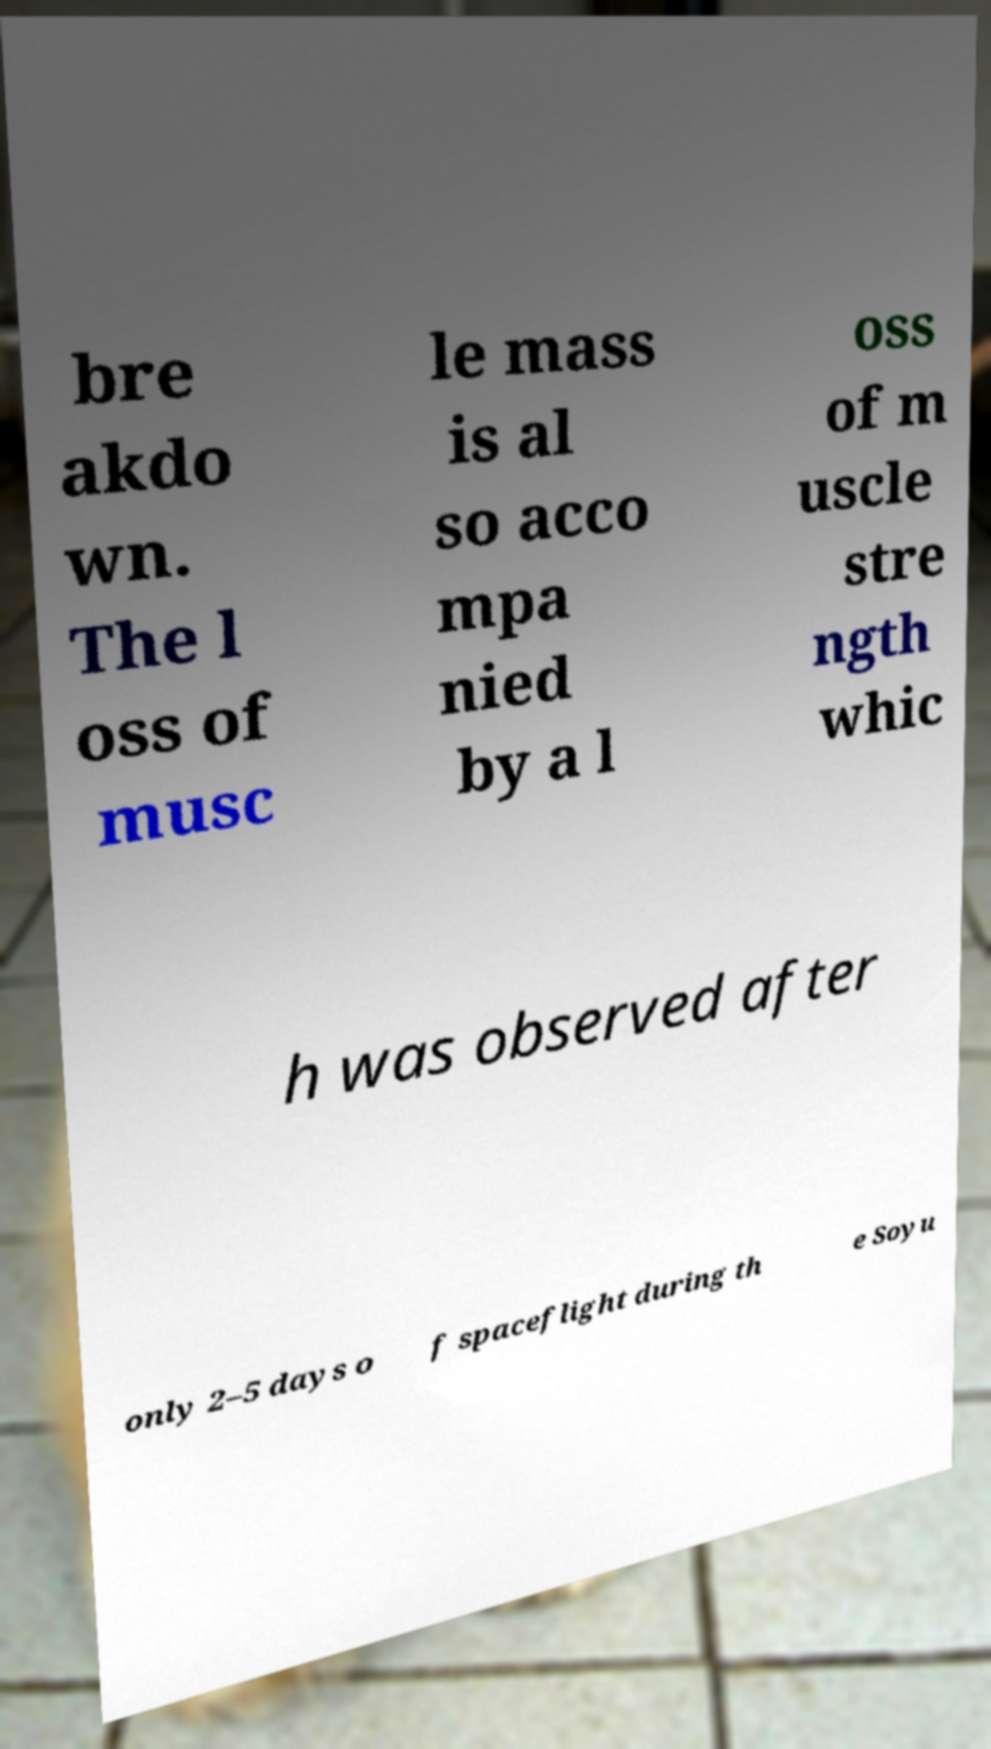Could you assist in decoding the text presented in this image and type it out clearly? bre akdo wn. The l oss of musc le mass is al so acco mpa nied by a l oss of m uscle stre ngth whic h was observed after only 2–5 days o f spaceflight during th e Soyu 